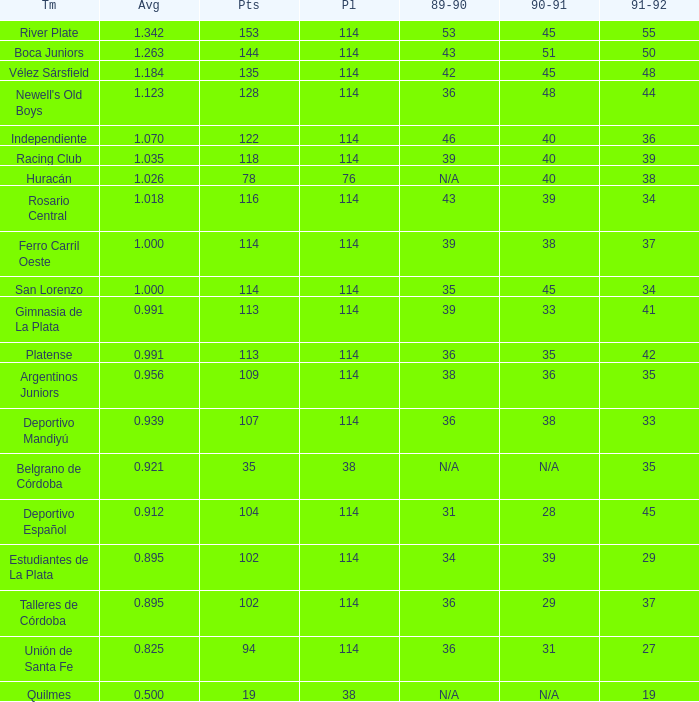How much Played has an Average smaller than 0.9390000000000001, and a 1990-91 of 28? 1.0. 